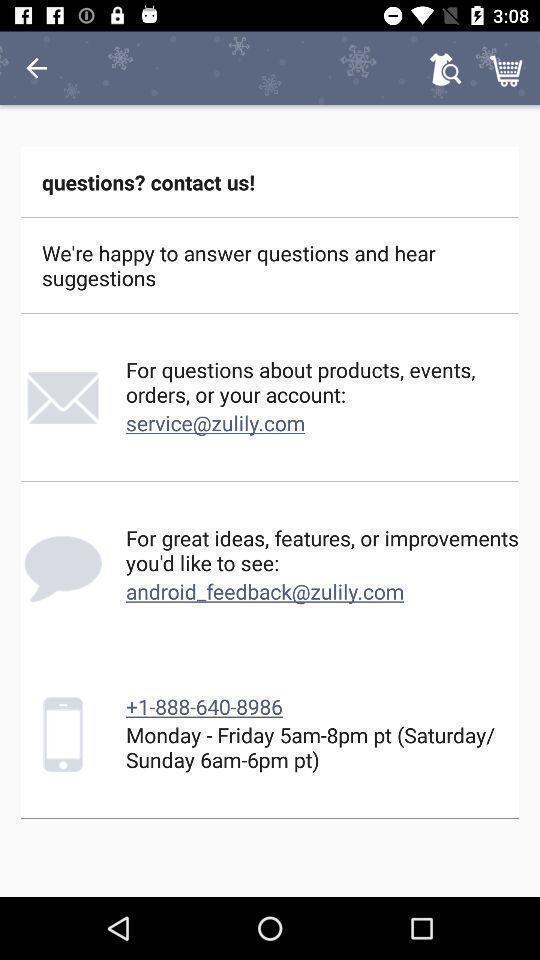Describe the key features of this screenshot. Page for asking questions suggestions of a shopping app. 